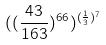<formula> <loc_0><loc_0><loc_500><loc_500>( ( \frac { 4 3 } { 1 6 3 } ) ^ { 6 6 } ) ^ { ( \frac { 1 } { 3 } ) ^ { 7 } }</formula> 